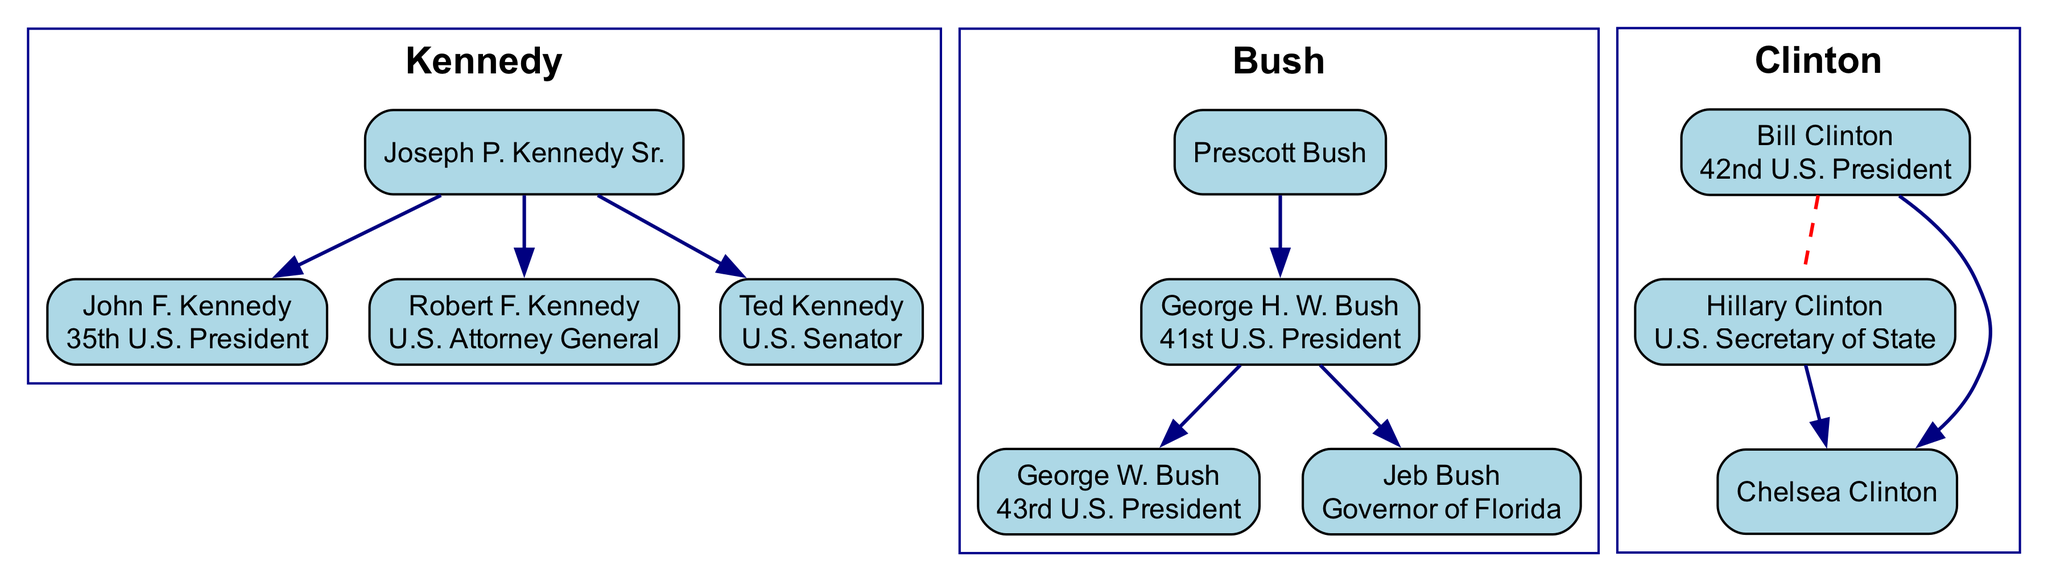What is the position of John F. Kennedy? John F. Kennedy is listed with the title "35th U.S. President" next to his name in the family tree.
Answer: 35th U.S. President How many members are in the Bush dynasty? The Bush dynasty has a total of four members listed: Prescott Bush, George H. W. Bush, George W. Bush, and Jeb Bush.
Answer: 4 Who is the spouse of Bill Clinton? The diagram indicates that Hillary Clinton is the listed spouse of Bill Clinton.
Answer: Hillary Clinton Which Kennedy is the U.S. Senator? The position of U.S. Senator is associated with Ted Kennedy in the diagram.
Answer: Ted Kennedy Who are the children of George H. W. Bush? The children of George H. W. Bush listed in the diagram are George W. Bush and Jeb Bush.
Answer: George W. Bush, Jeb Bush Which political positions are associated with members of the Clinton dynasty? The diagram shows Bill Clinton as the "42nd U.S. President" and Hillary Clinton as "U.S. Secretary of State," indicating their political roles.
Answer: 42nd U.S. President, U.S. Secretary of State Who does Joseph P. Kennedy Sr. have as children? The diagram clearly indicates that Joseph P. Kennedy Sr. has three children: John F. Kennedy, Robert F. Kennedy, and Ted Kennedy.
Answer: John F. Kennedy, Robert F. Kennedy, Ted Kennedy What is the relationship between George W. Bush and George H. W. Bush? The family tree explicitly indicates that George W. Bush is the child of George H. W. Bush, illustrating a direct lineage relationship.
Answer: Child Who is the parent of Chelsea Clinton? According to the diagram, Chelsea Clinton is the child of Bill Clinton and Hillary Clinton, indicating both as her parents.
Answer: Bill Clinton, Hillary Clinton 